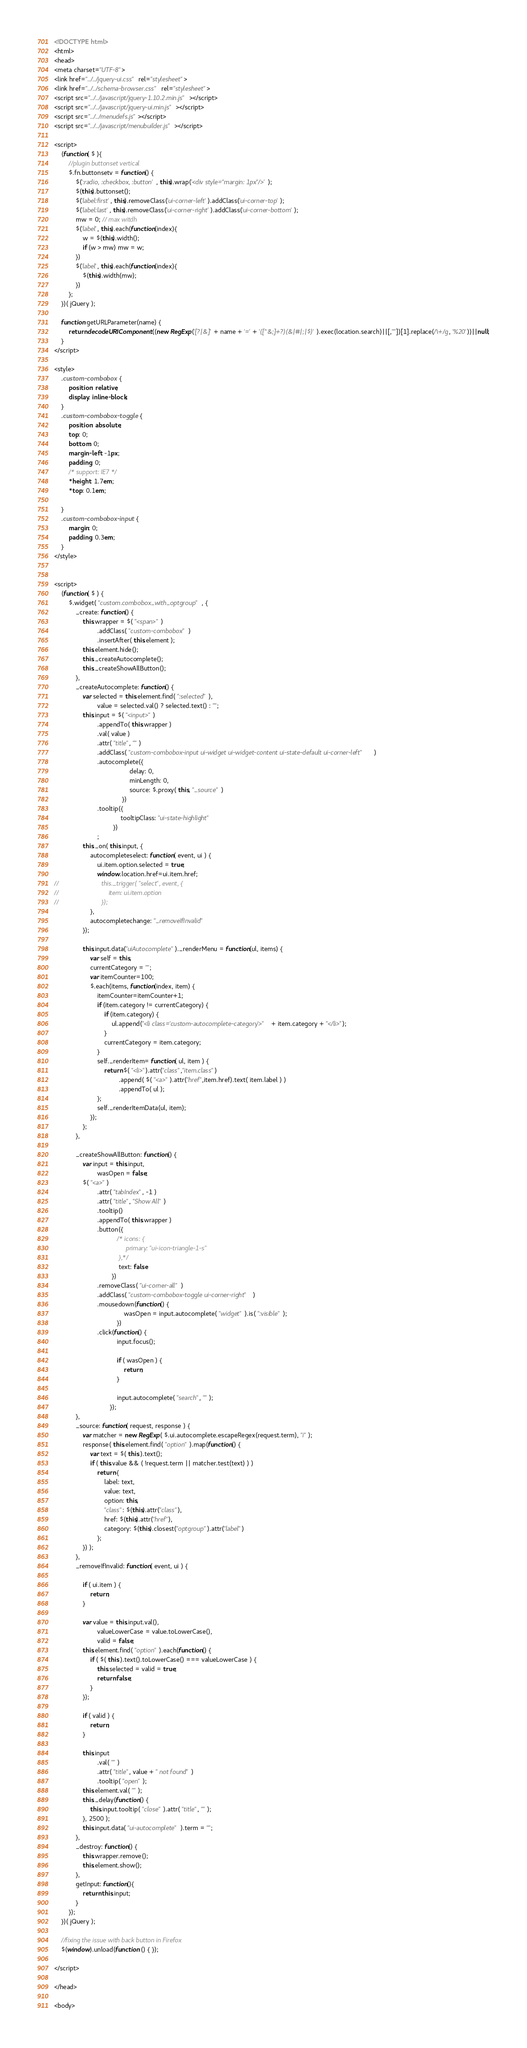<code> <loc_0><loc_0><loc_500><loc_500><_HTML_><!DOCTYPE html>
<html>
<head>
<meta charset="UTF-8">
<link href="../../jquery-ui.css" rel="stylesheet">
<link href="../../schema-browser.css" rel="stylesheet">
<script src="../../javascript/jquery-1.10.2.min.js"></script>
<script src="../../javascript/jquery-ui.min.js"></script>
<script src="../../menudefs.js"></script>
<script src="../../javascript/menubuilder.js"></script>

<script>
    (function( $ ){
        //plugin buttonset vertical
        $.fn.buttonsetv = function() {
            $(':radio, :checkbox, :button', this).wrap('<div style="margin: 1px"/>');
            $(this).buttonset();
            $('label:first', this).removeClass('ui-corner-left').addClass('ui-corner-top');
            $('label:last', this).removeClass('ui-corner-right').addClass('ui-corner-bottom');
            mw = 0; // max witdh
            $('label', this).each(function(index){
                w = $(this).width();
                if (w > mw) mw = w;
            })
            $('label', this).each(function(index){
                $(this).width(mw);
            })
        };
    })( jQuery );

    function getURLParameter(name) {
        return decodeURIComponent((new RegExp('[?|&]' + name + '=' + '([^&;]+?)(&|#|;|$)').exec(location.search)||[,""])[1].replace(/\+/g, '%20'))||null;
    }
</script>

<style>
    .custom-combobox {
        position: relative;
        display: inline-block;
    }
    .custom-combobox-toggle {
        position: absolute;
        top: 0;
        bottom: 0;
        margin-left: -1px;
        padding: 0;
        /* support: IE7 */
        *height: 1.7em;
        *top: 0.1em;

    }
    .custom-combobox-input {
        margin: 0;
        padding: 0.3em;
    }
</style>


<script>
    (function( $ ) {
        $.widget( "custom.combobox_with_optgroup", {
            _create: function() {
                this.wrapper = $( "<span>" )
                        .addClass( "custom-combobox" )
                        .insertAfter( this.element );
                this.element.hide();
                this._createAutocomplete();
                this._createShowAllButton();
            },
            _createAutocomplete: function() {
                var selected = this.element.find( ":selected" ),
                        value = selected.val() ? selected.text() : "";
                this.input = $( "<input>" )
                        .appendTo( this.wrapper )
                        .val( value )
                        .attr( "title", "" )
                        .addClass( "custom-combobox-input ui-widget ui-widget-content ui-state-default ui-corner-left" )
                        .autocomplete({
                                          delay: 0,
                                          minLength: 0,
                                          source: $.proxy( this, "_source" )
                                      })
                        .tooltip({
                                     tooltipClass: "ui-state-highlight"
                                 })
                        ;
                this._on( this.input, {
                    autocompleteselect: function( event, ui ) {
                        ui.item.option.selected = true;
                        window.location.href=ui.item.href;
//                        this._trigger( "select", event, {
//                            item: ui.item.option
//                        });
                    },
                    autocompletechange: "_removeIfInvalid"
                });

                this.input.data("uiAutocomplete")._renderMenu = function(ul, items) {
                    var self = this,
                    currentCategory = "";
                    var itemCounter=100;
                    $.each(items, function(index, item) {
                        itemCounter=itemCounter+1;
                        if (item.category != currentCategory) {
                            if (item.category) {
                                ul.append("<li class='custom-autocomplete-category'>" + item.category + "</li>");
                            }
                            currentCategory = item.category;
                        }
                        self._renderItem= function( ul, item ) {
                            return $( "<li>").attr("class","item.class")
                                    .append( $( "<a>" ).attr("href",item.href).text( item.label ) )
                                    .appendTo( ul );
                        };
                        self._renderItemData(ul, item);
                    });
                };
            },

            _createShowAllButton: function() {
                var input = this.input,
                        wasOpen = false;
                $( "<a>" )
                        .attr( "tabIndex", -1 )
                        .attr( "title", "Show All" )
                        .tooltip()
                        .appendTo( this.wrapper )
                        .button({
                                   /* icons: {
                                        primary: "ui-icon-triangle-1-s"
                                    },*/
                                    text: false
                                })
                        .removeClass( "ui-corner-all" )
                        .addClass( "custom-combobox-toggle ui-corner-right" )
                        .mousedown(function() {
                                       wasOpen = input.autocomplete( "widget" ).is( ":visible" );
                                   })
                        .click(function() {
                                   input.focus();

                                   if ( wasOpen ) {
                                       return;
                                   }

                                   input.autocomplete( "search", "" );
                               });
            },
            _source: function( request, response ) {
                var matcher = new RegExp( $.ui.autocomplete.escapeRegex(request.term), "i" );
                response( this.element.find( "option" ).map(function() {
                    var text = $( this ).text();
                    if ( this.value && ( !request.term || matcher.test(text) ) )
                        return {
                            label: text,
                            value: text,
                            option: this,
                            "class": $(this).attr("class"),
                            href: $(this).attr("href"),
                            category: $(this).closest("optgroup").attr("label")
                        };
                }) );
            },
            _removeIfInvalid: function( event, ui ) {

                if ( ui.item ) {
                    return;
                }

                var value = this.input.val(),
                        valueLowerCase = value.toLowerCase(),
                        valid = false;
                this.element.find( "option" ).each(function() {
                    if ( $( this ).text().toLowerCase() === valueLowerCase ) {
                        this.selected = valid = true;
                        return false;
                    }
                });

                if ( valid ) {
                    return;
                }

                this.input
                        .val( "" )
                        .attr( "title", value + " not found" )
                        .tooltip( "open" );
                this.element.val( "" );
                this._delay(function() {
                    this.input.tooltip( "close" ).attr( "title", "" );
                }, 2500 );
                this.input.data( "ui-autocomplete" ).term = "";
            },
            _destroy: function() {
                this.wrapper.remove();
                this.element.show();
            },
            getInput: function(){
                return this.input;
            }
        });
    })( jQuery );

    //fixing the issue with back button in Firefox
    $(window).unload(function () { });

</script>

</head>

<body>
</code> 